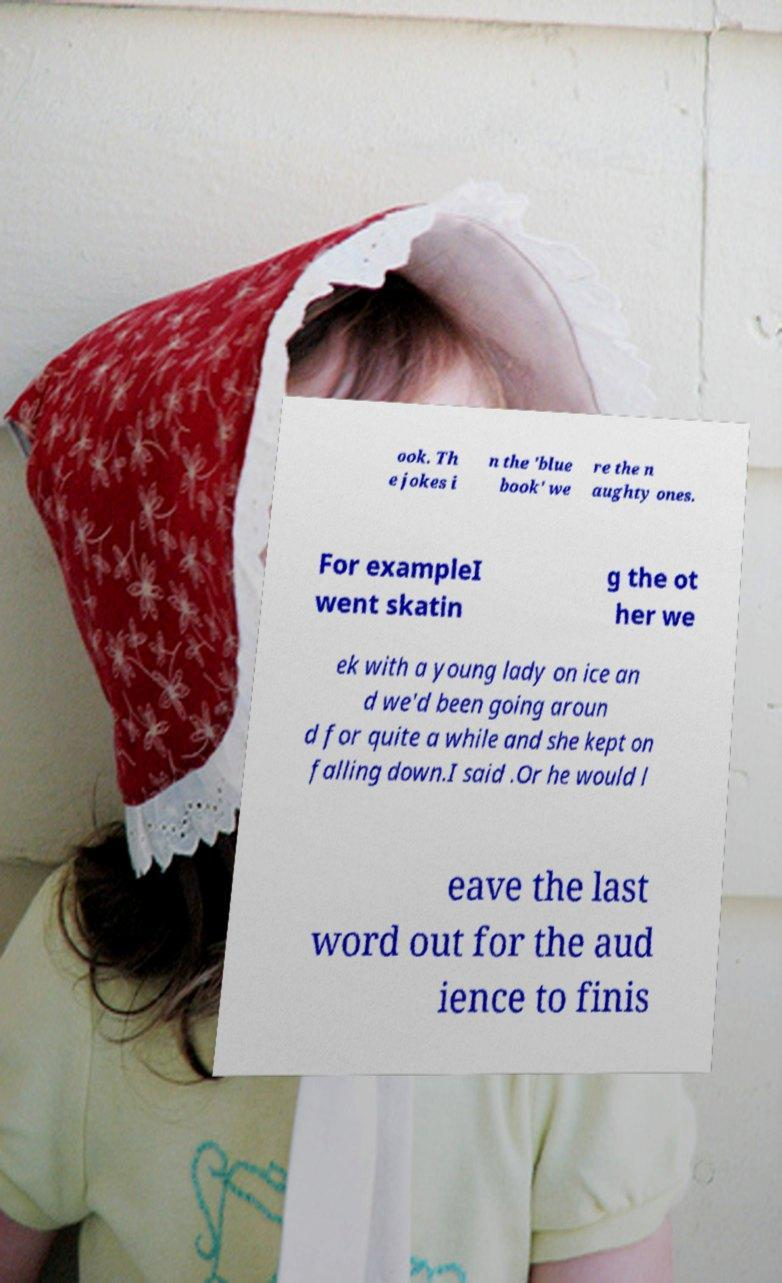I need the written content from this picture converted into text. Can you do that? ook. Th e jokes i n the 'blue book' we re the n aughty ones. For exampleI went skatin g the ot her we ek with a young lady on ice an d we'd been going aroun d for quite a while and she kept on falling down.I said .Or he would l eave the last word out for the aud ience to finis 